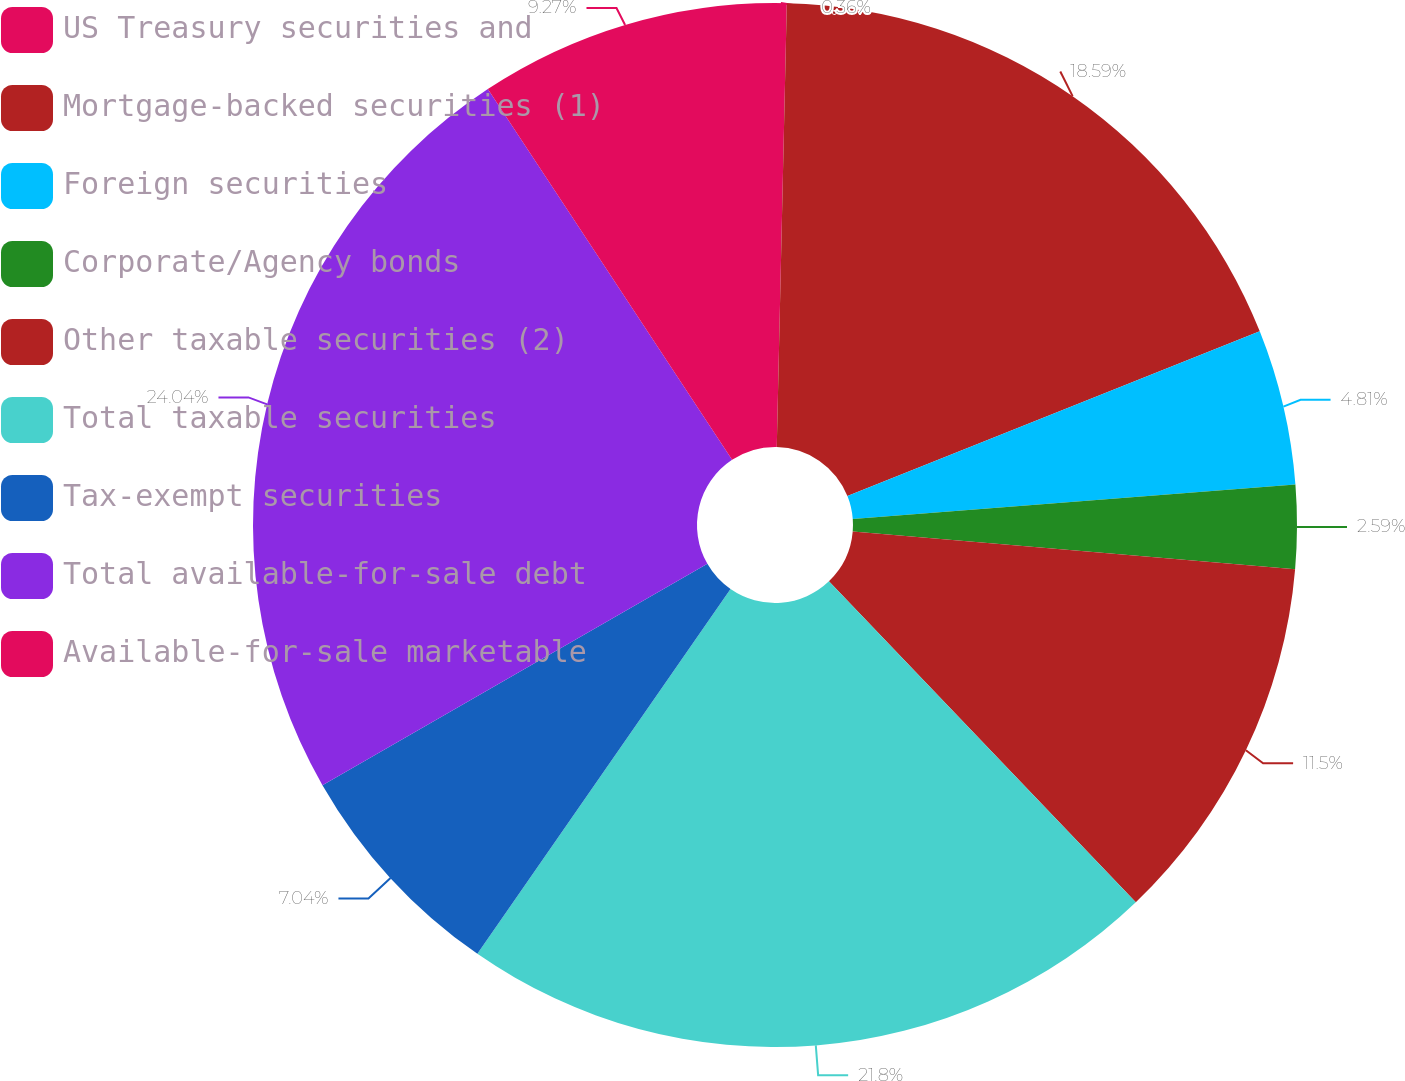<chart> <loc_0><loc_0><loc_500><loc_500><pie_chart><fcel>US Treasury securities and<fcel>Mortgage-backed securities (1)<fcel>Foreign securities<fcel>Corporate/Agency bonds<fcel>Other taxable securities (2)<fcel>Total taxable securities<fcel>Tax-exempt securities<fcel>Total available-for-sale debt<fcel>Available-for-sale marketable<nl><fcel>0.36%<fcel>18.59%<fcel>4.81%<fcel>2.59%<fcel>11.5%<fcel>21.8%<fcel>7.04%<fcel>24.03%<fcel>9.27%<nl></chart> 